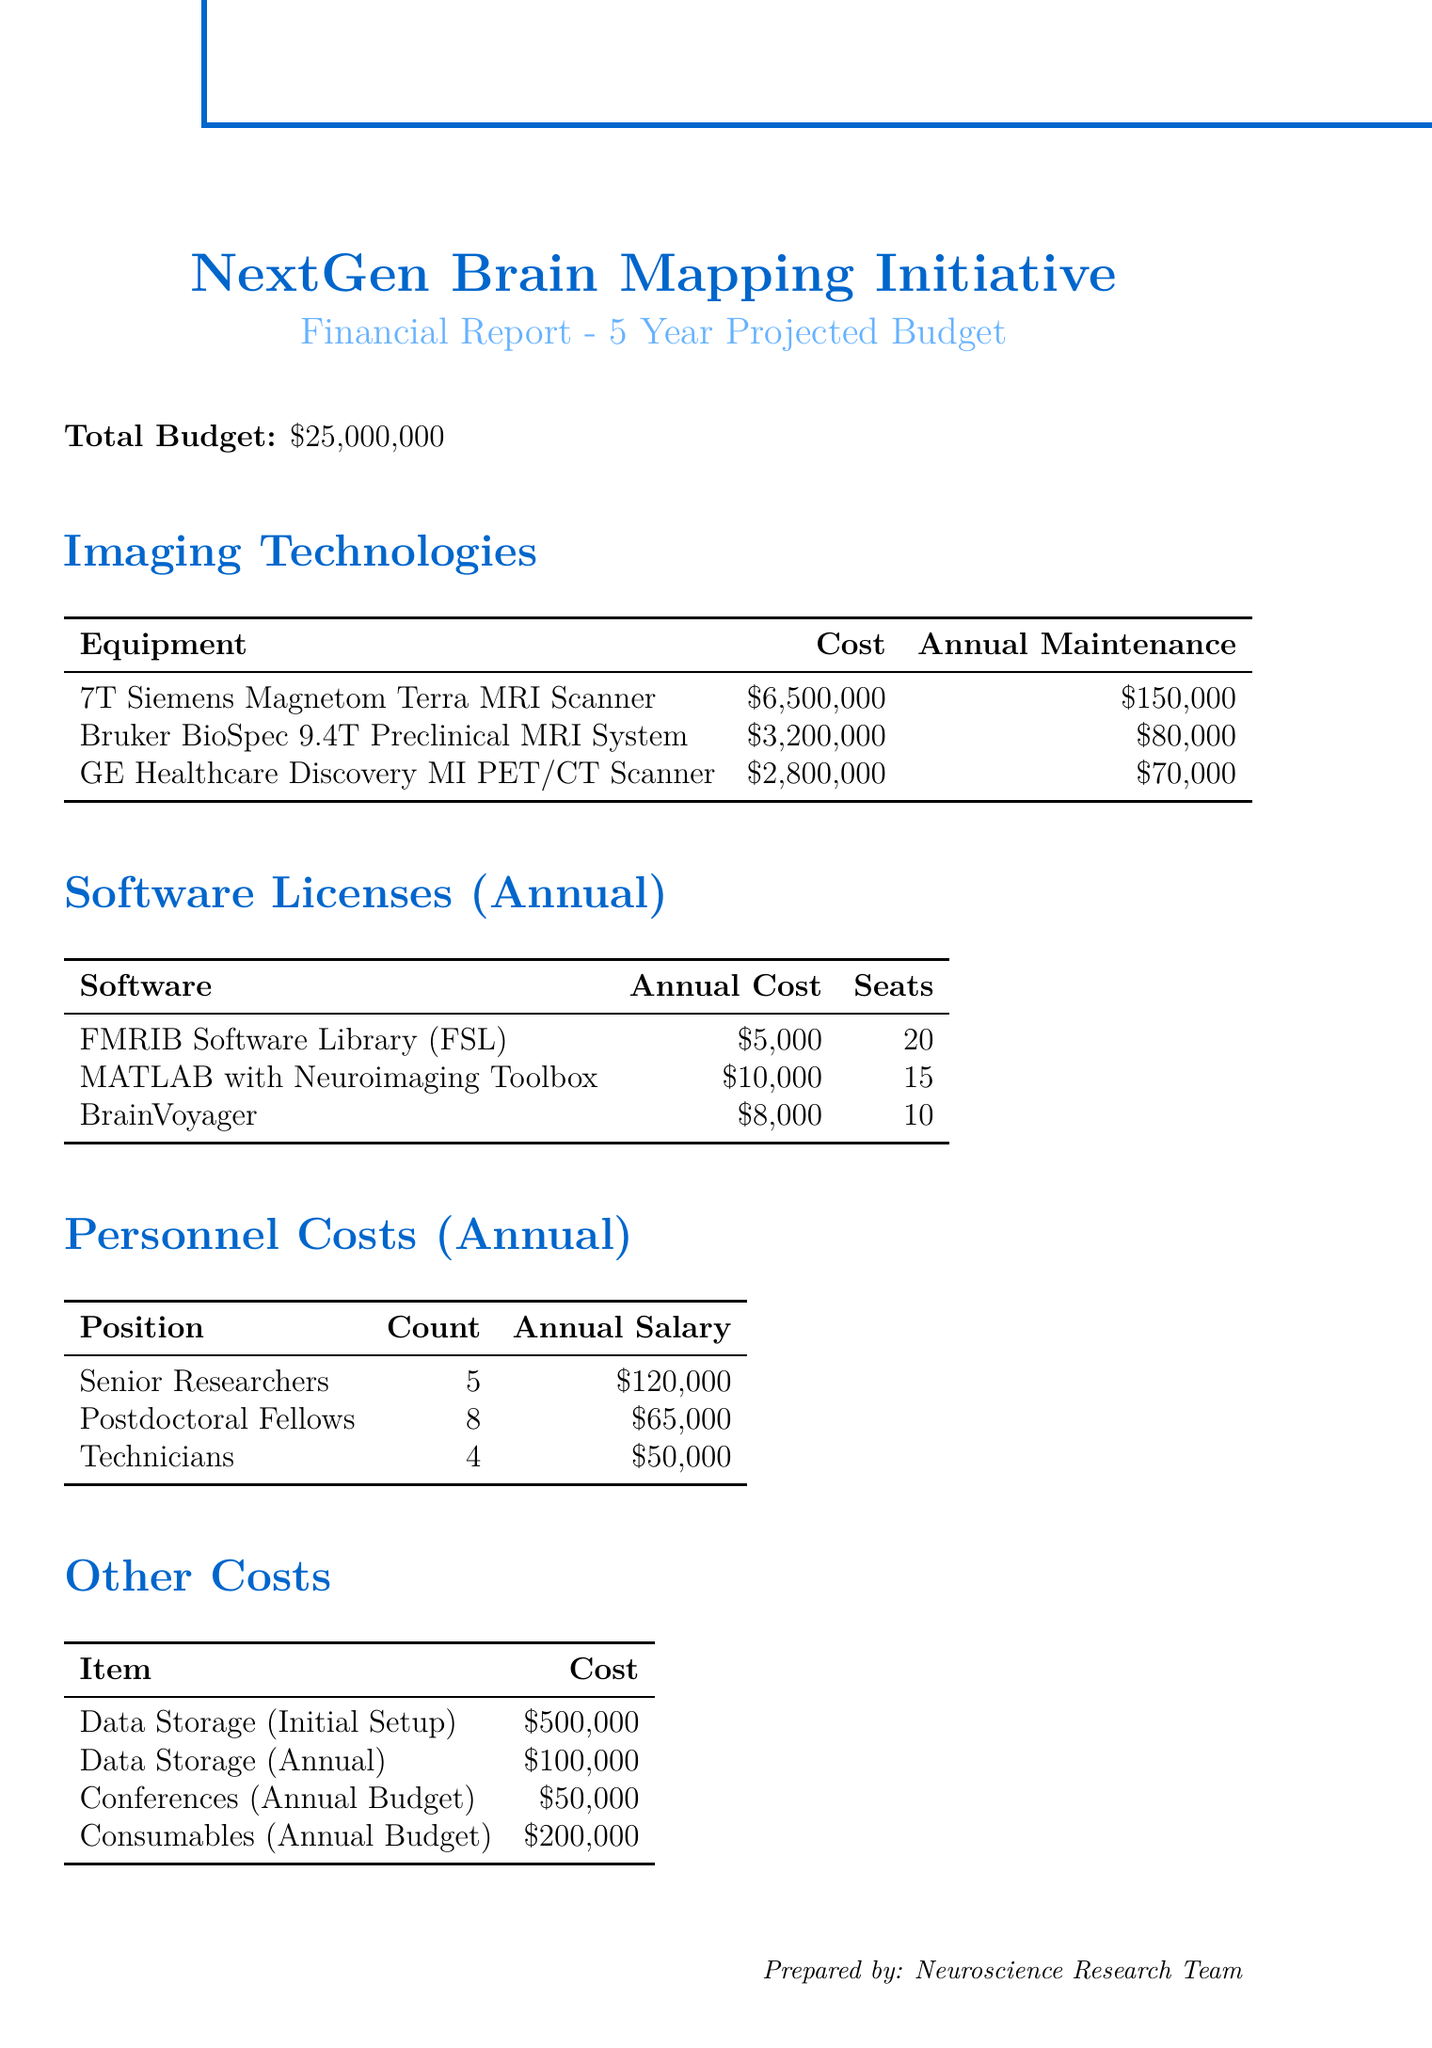What is the total budget for the initiative? The total budget is explicitly stated in the document as $25,000,000.
Answer: $25,000,000 How many years will the project last? The duration of the project is specified as 5 years.
Answer: 5 years What is the annual maintenance cost for the 7T Siemens Magnetom Terra MRI Scanner? The document states the annual maintenance cost for this scanner is $150,000.
Answer: $150,000 How many senior researchers are planned for this project? The document indicates that there will be 5 senior researchers involved in the project.
Answer: 5 What is the total annual cost for the software licenses? To find the total, add the annual costs of the software licenses: $5,000 + $10,000 + $8,000 = $23,000.
Answer: $23,000 What is the annual budget allocated for conferences? The annual budget for conferences is clearly stated in the document as $50,000.
Answer: $50,000 Which imaging technology has the highest cost? The document lists the 7T Siemens Magnetom Terra MRI Scanner as the most expensive technology at $6,500,000.
Answer: 7T Siemens Magnetom Terra MRI Scanner What percentage of the total budget is allocated for personnel costs each year? The total annual personnel costs can be calculated: (5 * $120,000) + (8 * $65,000) + (4 * $50,000) = $1,185,000. The percentage is ($1,185,000 / $25,000,000) * 100 = 4.74%.
Answer: 4.74% How much is budgeted annually for consumables? The annual budget for consumables is specifically detailed in the document as $200,000.
Answer: $200,000 